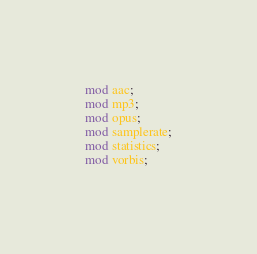Convert code to text. <code><loc_0><loc_0><loc_500><loc_500><_Rust_>mod aac;
mod mp3;
mod opus;
mod samplerate;
mod statistics;
mod vorbis;
</code> 